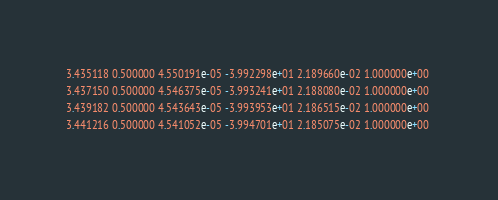<code> <loc_0><loc_0><loc_500><loc_500><_SQL_>3.435118 0.500000 4.550191e-05 -3.992298e+01 2.189660e-02 1.000000e+00 
3.437150 0.500000 4.546375e-05 -3.993241e+01 2.188080e-02 1.000000e+00 
3.439182 0.500000 4.543643e-05 -3.993953e+01 2.186515e-02 1.000000e+00 
3.441216 0.500000 4.541052e-05 -3.994701e+01 2.185075e-02 1.000000e+00 </code> 